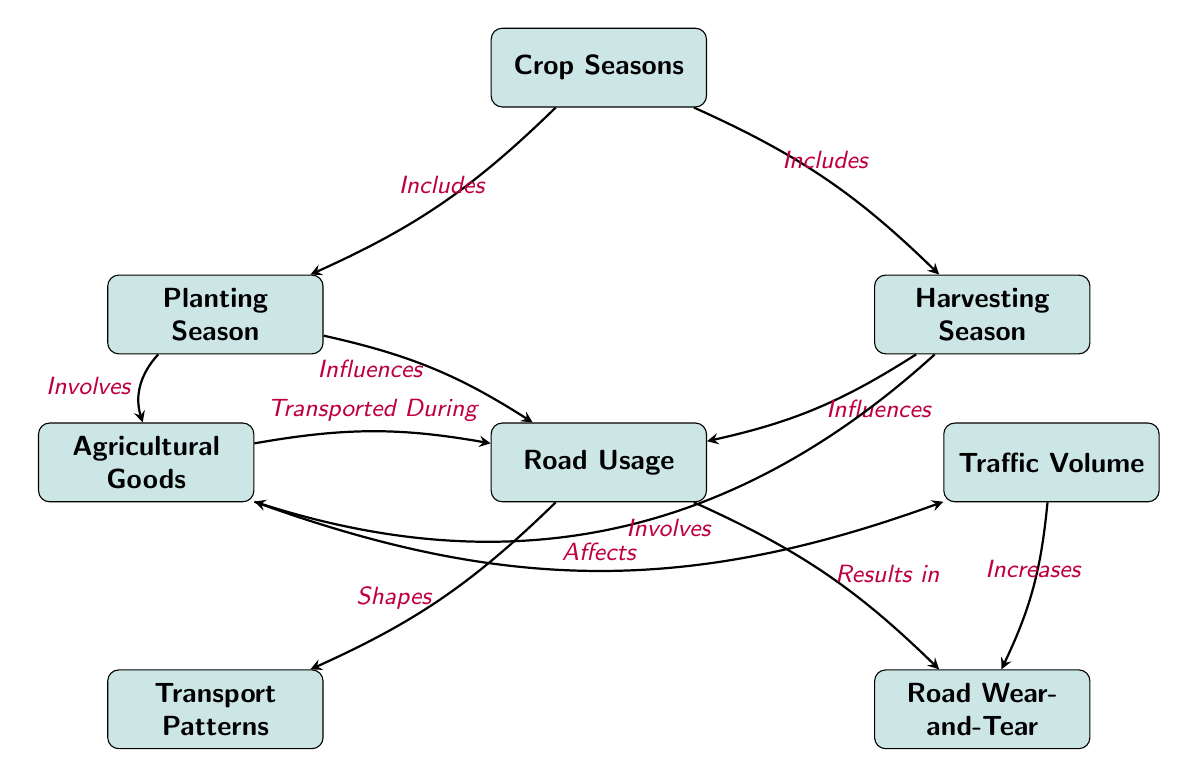What are the two main crop seasons depicted in the diagram? The diagram shows two nodes related to crop seasons: "Planting Season" and "Harvesting Season." These nodes are directly connected to the "Crop Seasons" node, indicating they are the two main crop seasons under study.
Answer: Planting Season, Harvesting Season How many nodes are in this diagram? By counting the individual nodes, we find a total of seven nodes: "Crop Seasons," "Planting Season," "Harvesting Season," "Road Usage," "Transport Patterns," "Road Wear-and-Tear," "Agricultural Goods," and "Traffic Volume."
Answer: Seven What does the "Harvesting Season" influence in the diagram? According to the diagram, "Harvesting Season" has a directed edge pointing to "Road Usage," showing that it influences road usage directly.
Answer: Road Usage What relationship does "Traffic Volume" have with "Road Wear-and-Tear"? The diagram indicates a direct relationship where "Traffic Volume" increases "Road Wear-and-Tear." The directed edge signifies that as the volume of traffic rises, it results in more wear and tear on the roads.
Answer: Increases What connects "Agricultural Goods" with "Road Usage"? There is a labeled edge connecting "Agricultural Goods" to "Road Usage" indicating that the goods are transported during road usage. This shows that the movement of agricultural goods directly affects how roads are used.
Answer: Transported During How do transporting goods during "Planting Season" affect "Traffic Volume"? Since "Planting Season" involves the transportation of agricultural goods, and these goods affect "Traffic Volume," we deduce that during this season, there is likely an increase in traffic volume due to the goods being transported to and from agricultural areas.
Answer: Affects What is a result of "Road Usage" according to the diagram? The diagram specifies that one of the results of "Road Usage" is "Road Wear-and-Tear," indicating a consequence of the patterns of road usage based on agricultural activities.
Answer: Road Wear-and-Tear Which node involves both types of crop seasons? The "Crop Seasons" node includes both the "Planting Season" and "Harvesting Season," as indicated by the connections from this central node to the two seasons.
Answer: Crop Seasons 